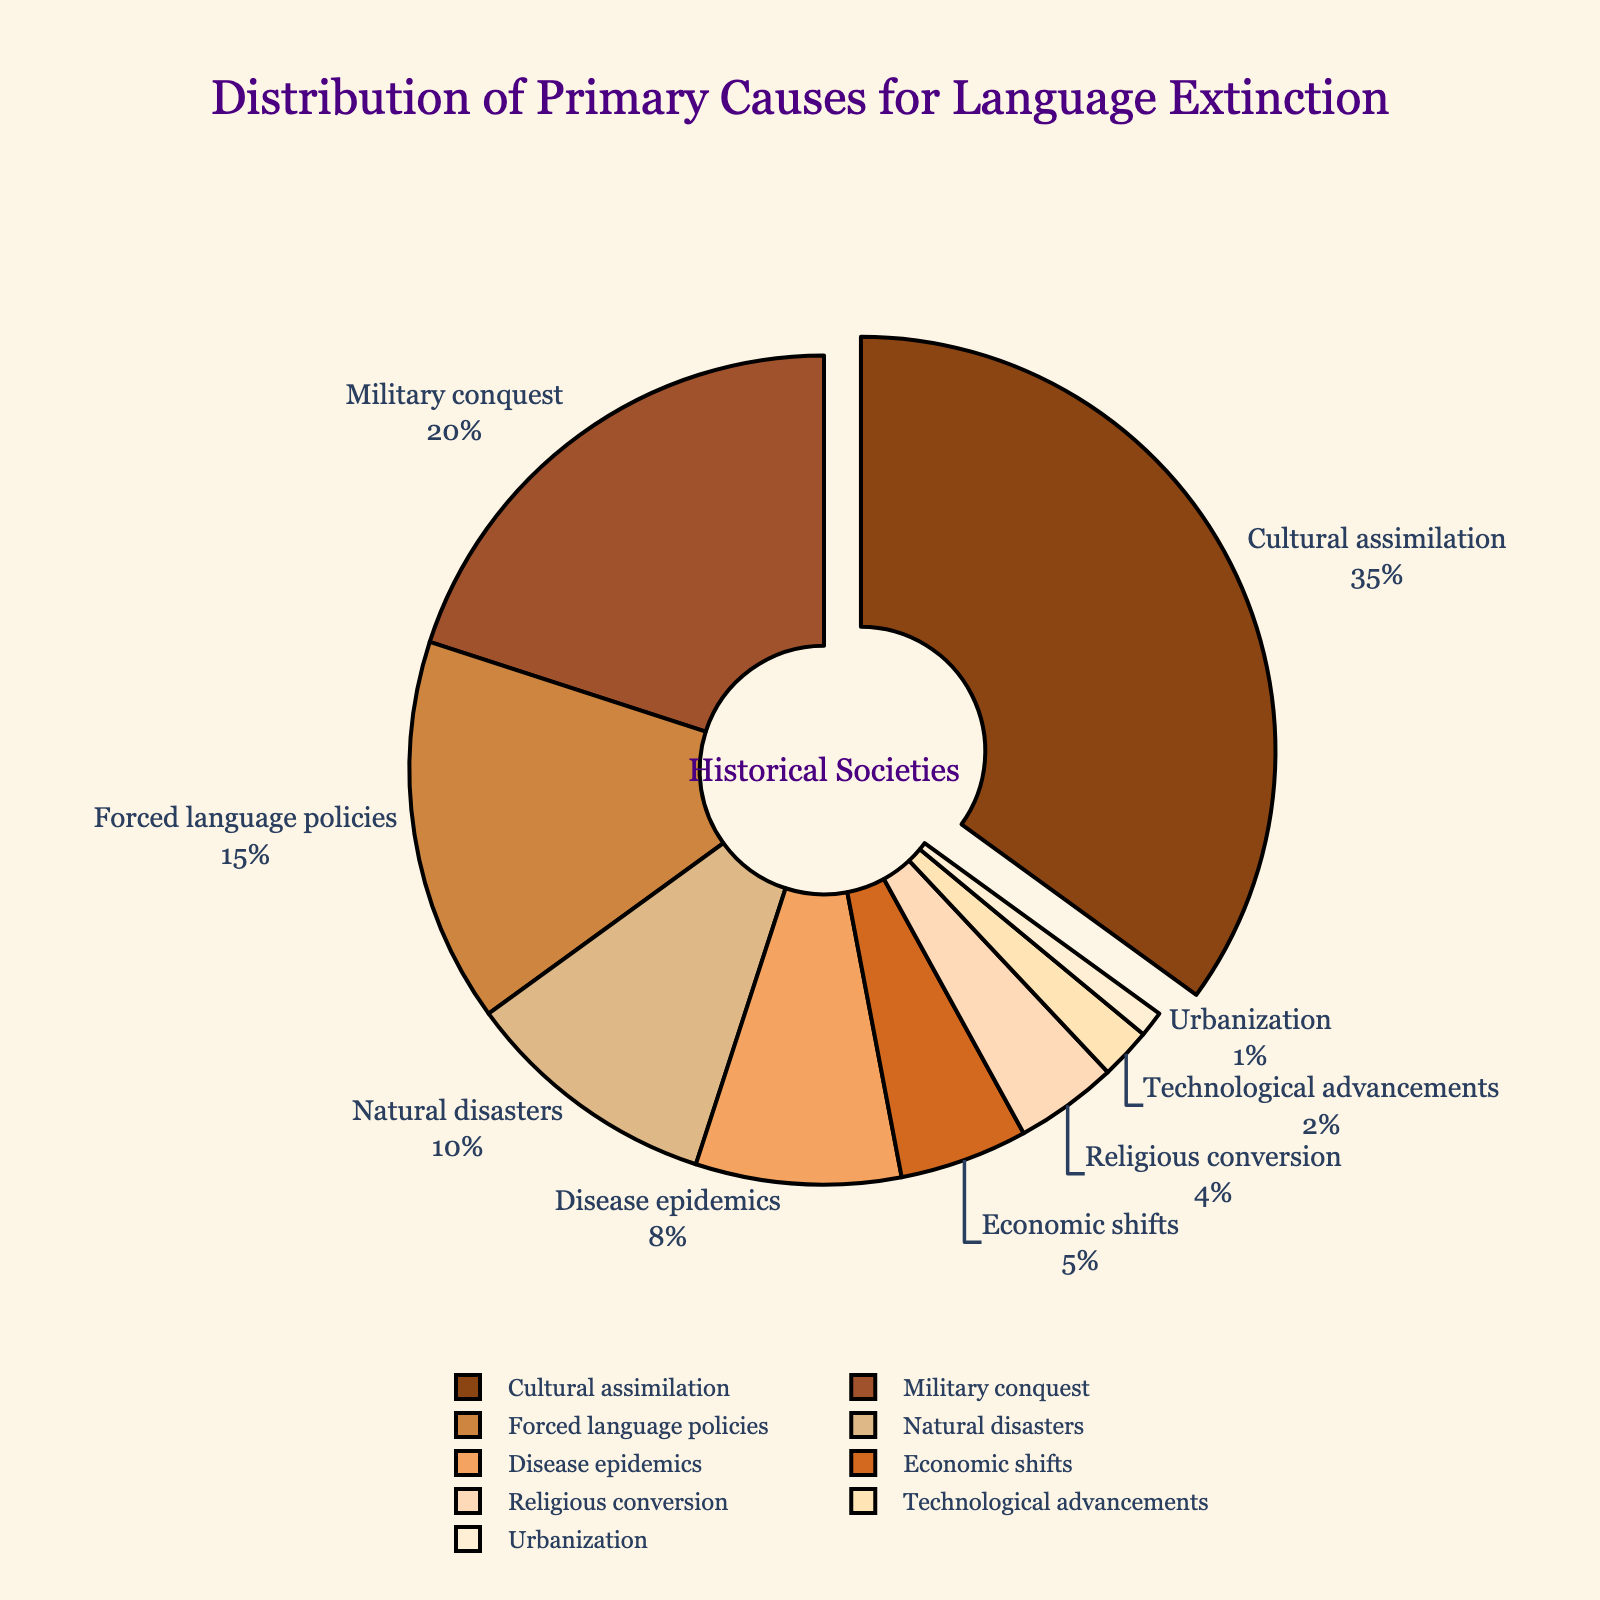Which cause has the highest percentage for language extinction? The chart shows percentages for various causes of language extinction. The largest segment is the 'Cultural assimilation' with 35%.
Answer: Cultural assimilation Which are the top three causes for language extinction? The chart displays the percentages of various causes. The top three segments with the highest percentages are 'Cultural assimilation' (35%), 'Military conquest' (20%), and 'Forced language policies' (15%).
Answer: Cultural assimilation, Military conquest, Forced language policies What is the combined percentage of 'Natural disasters' and 'Disease epidemics'? The percentages shown are 10% for 'Natural disasters' and 8% for 'Disease epidemics'. Adding these together gives 10% + 8% = 18%.
Answer: 18% How does 'Economic shifts' compare to 'Religious conversion' in terms of percentage contribution? According to the pie chart, 'Economic shifts' accounts for 5%, whereas 'Religious conversion' accounts for 4%. Thus, 'Economic shifts' has a 1% higher contribution than 'Religious conversion'.
Answer: Economic shifts > Religious conversion Which cause has the smallest impact on language extinction according to the data? By looking at the smallest segment in the chart, it is identified as 'Urbanization' with 1%.
Answer: Urbanization What is the difference in percentage between 'Cultural assimilation' and 'Military conquest'? The chart shows 'Cultural assimilation' at 35% and 'Military conquest' at 20%. The difference is 35% - 20% = 15%.
Answer: 15% Name two causes that together make up less than 10% of the total percentage. From the chart, 'Technological advancements' (2%) and 'Urbanization' (1%) add up to 2% + 1% = 3%, which is less than 10%.
Answer: Technological advancements, Urbanization What visual attribute distinguishes the cause with the highest percentage? The 'Cultural assimilation' segment is visually pulled out from the pie chart, differentiating it from other segments.
Answer: Pulled out segment How many causes have a percentage above 10%? The chart segments with percentages above 10% are 'Cultural assimilation' (35%), 'Military conquest' (20%), and 'Forced language policies' (15%). Therefore, there are three such causes.
Answer: 3 